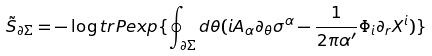Convert formula to latex. <formula><loc_0><loc_0><loc_500><loc_500>\tilde { S } _ { \partial \Sigma } = - \log t r P e x p \{ \oint _ { \partial \Sigma } d \theta ( i A _ { \alpha } \partial _ { \theta } \sigma ^ { \alpha } - \frac { 1 } { 2 \pi \alpha ^ { \prime } } \Phi _ { i } \partial _ { r } X ^ { i } ) \}</formula> 